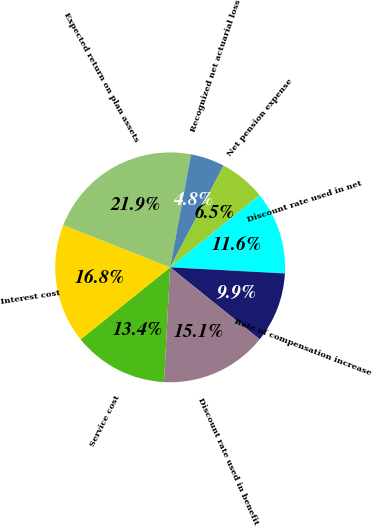<chart> <loc_0><loc_0><loc_500><loc_500><pie_chart><fcel>Service cost<fcel>Interest cost<fcel>Expected return on plan assets<fcel>Recognized net actuarial loss<fcel>Net pension expense<fcel>Discount rate used in net<fcel>Rate of compensation increase<fcel>Discount rate used in benefit<nl><fcel>13.36%<fcel>16.78%<fcel>21.92%<fcel>4.79%<fcel>6.5%<fcel>11.64%<fcel>9.93%<fcel>15.07%<nl></chart> 